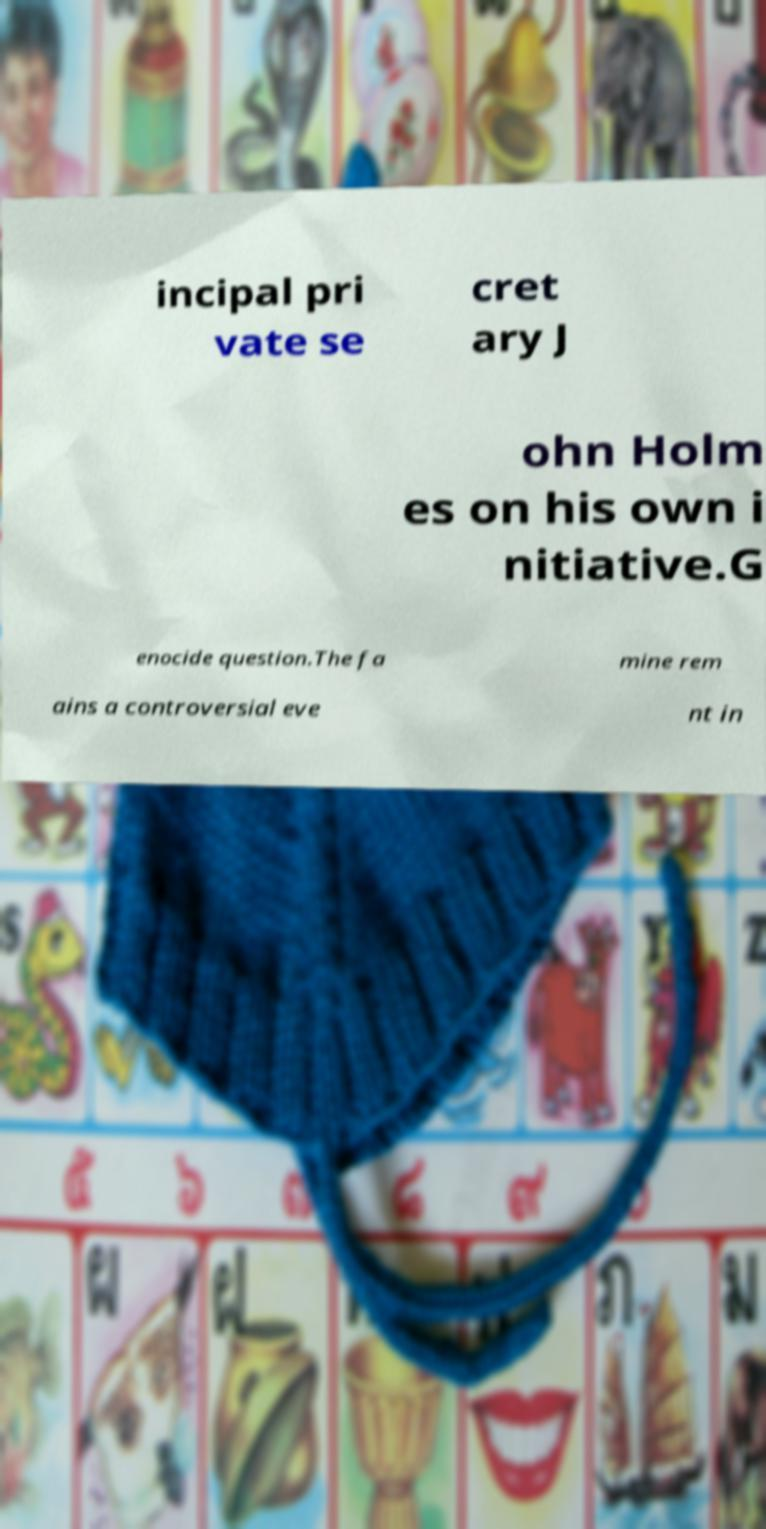Could you assist in decoding the text presented in this image and type it out clearly? incipal pri vate se cret ary J ohn Holm es on his own i nitiative.G enocide question.The fa mine rem ains a controversial eve nt in 